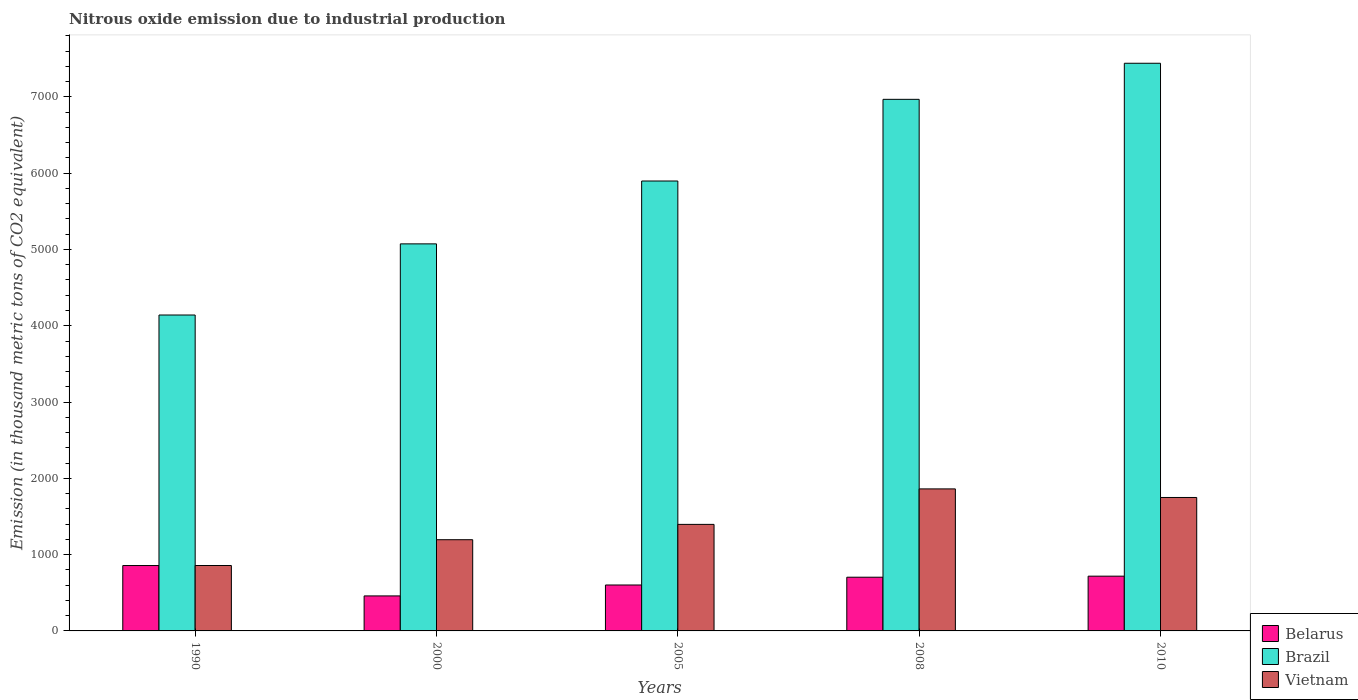How many different coloured bars are there?
Your response must be concise. 3. In how many cases, is the number of bars for a given year not equal to the number of legend labels?
Your answer should be compact. 0. What is the amount of nitrous oxide emitted in Brazil in 2010?
Provide a succinct answer. 7440.7. Across all years, what is the maximum amount of nitrous oxide emitted in Brazil?
Your response must be concise. 7440.7. Across all years, what is the minimum amount of nitrous oxide emitted in Brazil?
Provide a short and direct response. 4140.8. What is the total amount of nitrous oxide emitted in Belarus in the graph?
Provide a succinct answer. 3339.7. What is the difference between the amount of nitrous oxide emitted in Brazil in 2008 and that in 2010?
Keep it short and to the point. -472.8. What is the difference between the amount of nitrous oxide emitted in Brazil in 2005 and the amount of nitrous oxide emitted in Vietnam in 1990?
Provide a short and direct response. 5039.9. What is the average amount of nitrous oxide emitted in Vietnam per year?
Your answer should be compact. 1412.02. In the year 2008, what is the difference between the amount of nitrous oxide emitted in Vietnam and amount of nitrous oxide emitted in Belarus?
Offer a very short reply. 1157.5. What is the ratio of the amount of nitrous oxide emitted in Vietnam in 1990 to that in 2000?
Your response must be concise. 0.72. Is the difference between the amount of nitrous oxide emitted in Vietnam in 2008 and 2010 greater than the difference between the amount of nitrous oxide emitted in Belarus in 2008 and 2010?
Offer a very short reply. Yes. What is the difference between the highest and the second highest amount of nitrous oxide emitted in Vietnam?
Offer a very short reply. 112.5. What is the difference between the highest and the lowest amount of nitrous oxide emitted in Vietnam?
Your answer should be very brief. 1004.2. Is the sum of the amount of nitrous oxide emitted in Belarus in 1990 and 2005 greater than the maximum amount of nitrous oxide emitted in Vietnam across all years?
Your answer should be compact. No. What does the 3rd bar from the left in 2000 represents?
Your answer should be compact. Vietnam. What does the 3rd bar from the right in 2008 represents?
Make the answer very short. Belarus. Are all the bars in the graph horizontal?
Your answer should be very brief. No. What is the difference between two consecutive major ticks on the Y-axis?
Your response must be concise. 1000. Are the values on the major ticks of Y-axis written in scientific E-notation?
Provide a short and direct response. No. Does the graph contain any zero values?
Your response must be concise. No. How many legend labels are there?
Give a very brief answer. 3. How are the legend labels stacked?
Provide a short and direct response. Vertical. What is the title of the graph?
Give a very brief answer. Nitrous oxide emission due to industrial production. What is the label or title of the Y-axis?
Make the answer very short. Emission (in thousand metric tons of CO2 equivalent). What is the Emission (in thousand metric tons of CO2 equivalent) in Belarus in 1990?
Keep it short and to the point. 857. What is the Emission (in thousand metric tons of CO2 equivalent) of Brazil in 1990?
Provide a succinct answer. 4140.8. What is the Emission (in thousand metric tons of CO2 equivalent) of Vietnam in 1990?
Your answer should be very brief. 857.4. What is the Emission (in thousand metric tons of CO2 equivalent) of Belarus in 2000?
Provide a succinct answer. 458.8. What is the Emission (in thousand metric tons of CO2 equivalent) in Brazil in 2000?
Give a very brief answer. 5073.4. What is the Emission (in thousand metric tons of CO2 equivalent) of Vietnam in 2000?
Your answer should be very brief. 1195.6. What is the Emission (in thousand metric tons of CO2 equivalent) in Belarus in 2005?
Provide a short and direct response. 602.1. What is the Emission (in thousand metric tons of CO2 equivalent) of Brazil in 2005?
Your answer should be very brief. 5897.3. What is the Emission (in thousand metric tons of CO2 equivalent) of Vietnam in 2005?
Make the answer very short. 1396.4. What is the Emission (in thousand metric tons of CO2 equivalent) in Belarus in 2008?
Make the answer very short. 704.1. What is the Emission (in thousand metric tons of CO2 equivalent) of Brazil in 2008?
Your response must be concise. 6967.9. What is the Emission (in thousand metric tons of CO2 equivalent) in Vietnam in 2008?
Your answer should be compact. 1861.6. What is the Emission (in thousand metric tons of CO2 equivalent) in Belarus in 2010?
Offer a terse response. 717.7. What is the Emission (in thousand metric tons of CO2 equivalent) of Brazil in 2010?
Make the answer very short. 7440.7. What is the Emission (in thousand metric tons of CO2 equivalent) of Vietnam in 2010?
Ensure brevity in your answer.  1749.1. Across all years, what is the maximum Emission (in thousand metric tons of CO2 equivalent) in Belarus?
Make the answer very short. 857. Across all years, what is the maximum Emission (in thousand metric tons of CO2 equivalent) in Brazil?
Your response must be concise. 7440.7. Across all years, what is the maximum Emission (in thousand metric tons of CO2 equivalent) of Vietnam?
Your answer should be compact. 1861.6. Across all years, what is the minimum Emission (in thousand metric tons of CO2 equivalent) of Belarus?
Your response must be concise. 458.8. Across all years, what is the minimum Emission (in thousand metric tons of CO2 equivalent) in Brazil?
Your answer should be very brief. 4140.8. Across all years, what is the minimum Emission (in thousand metric tons of CO2 equivalent) in Vietnam?
Provide a short and direct response. 857.4. What is the total Emission (in thousand metric tons of CO2 equivalent) of Belarus in the graph?
Your answer should be very brief. 3339.7. What is the total Emission (in thousand metric tons of CO2 equivalent) in Brazil in the graph?
Make the answer very short. 2.95e+04. What is the total Emission (in thousand metric tons of CO2 equivalent) of Vietnam in the graph?
Provide a short and direct response. 7060.1. What is the difference between the Emission (in thousand metric tons of CO2 equivalent) in Belarus in 1990 and that in 2000?
Provide a short and direct response. 398.2. What is the difference between the Emission (in thousand metric tons of CO2 equivalent) of Brazil in 1990 and that in 2000?
Provide a succinct answer. -932.6. What is the difference between the Emission (in thousand metric tons of CO2 equivalent) of Vietnam in 1990 and that in 2000?
Your response must be concise. -338.2. What is the difference between the Emission (in thousand metric tons of CO2 equivalent) in Belarus in 1990 and that in 2005?
Ensure brevity in your answer.  254.9. What is the difference between the Emission (in thousand metric tons of CO2 equivalent) of Brazil in 1990 and that in 2005?
Provide a succinct answer. -1756.5. What is the difference between the Emission (in thousand metric tons of CO2 equivalent) of Vietnam in 1990 and that in 2005?
Keep it short and to the point. -539. What is the difference between the Emission (in thousand metric tons of CO2 equivalent) in Belarus in 1990 and that in 2008?
Keep it short and to the point. 152.9. What is the difference between the Emission (in thousand metric tons of CO2 equivalent) of Brazil in 1990 and that in 2008?
Ensure brevity in your answer.  -2827.1. What is the difference between the Emission (in thousand metric tons of CO2 equivalent) of Vietnam in 1990 and that in 2008?
Keep it short and to the point. -1004.2. What is the difference between the Emission (in thousand metric tons of CO2 equivalent) of Belarus in 1990 and that in 2010?
Your response must be concise. 139.3. What is the difference between the Emission (in thousand metric tons of CO2 equivalent) in Brazil in 1990 and that in 2010?
Your answer should be very brief. -3299.9. What is the difference between the Emission (in thousand metric tons of CO2 equivalent) in Vietnam in 1990 and that in 2010?
Make the answer very short. -891.7. What is the difference between the Emission (in thousand metric tons of CO2 equivalent) of Belarus in 2000 and that in 2005?
Ensure brevity in your answer.  -143.3. What is the difference between the Emission (in thousand metric tons of CO2 equivalent) in Brazil in 2000 and that in 2005?
Keep it short and to the point. -823.9. What is the difference between the Emission (in thousand metric tons of CO2 equivalent) in Vietnam in 2000 and that in 2005?
Give a very brief answer. -200.8. What is the difference between the Emission (in thousand metric tons of CO2 equivalent) of Belarus in 2000 and that in 2008?
Provide a succinct answer. -245.3. What is the difference between the Emission (in thousand metric tons of CO2 equivalent) in Brazil in 2000 and that in 2008?
Offer a terse response. -1894.5. What is the difference between the Emission (in thousand metric tons of CO2 equivalent) of Vietnam in 2000 and that in 2008?
Provide a succinct answer. -666. What is the difference between the Emission (in thousand metric tons of CO2 equivalent) in Belarus in 2000 and that in 2010?
Your response must be concise. -258.9. What is the difference between the Emission (in thousand metric tons of CO2 equivalent) in Brazil in 2000 and that in 2010?
Your response must be concise. -2367.3. What is the difference between the Emission (in thousand metric tons of CO2 equivalent) in Vietnam in 2000 and that in 2010?
Your response must be concise. -553.5. What is the difference between the Emission (in thousand metric tons of CO2 equivalent) of Belarus in 2005 and that in 2008?
Your response must be concise. -102. What is the difference between the Emission (in thousand metric tons of CO2 equivalent) of Brazil in 2005 and that in 2008?
Offer a very short reply. -1070.6. What is the difference between the Emission (in thousand metric tons of CO2 equivalent) of Vietnam in 2005 and that in 2008?
Offer a terse response. -465.2. What is the difference between the Emission (in thousand metric tons of CO2 equivalent) of Belarus in 2005 and that in 2010?
Your response must be concise. -115.6. What is the difference between the Emission (in thousand metric tons of CO2 equivalent) in Brazil in 2005 and that in 2010?
Make the answer very short. -1543.4. What is the difference between the Emission (in thousand metric tons of CO2 equivalent) of Vietnam in 2005 and that in 2010?
Your answer should be very brief. -352.7. What is the difference between the Emission (in thousand metric tons of CO2 equivalent) of Belarus in 2008 and that in 2010?
Your response must be concise. -13.6. What is the difference between the Emission (in thousand metric tons of CO2 equivalent) in Brazil in 2008 and that in 2010?
Give a very brief answer. -472.8. What is the difference between the Emission (in thousand metric tons of CO2 equivalent) of Vietnam in 2008 and that in 2010?
Provide a short and direct response. 112.5. What is the difference between the Emission (in thousand metric tons of CO2 equivalent) of Belarus in 1990 and the Emission (in thousand metric tons of CO2 equivalent) of Brazil in 2000?
Provide a succinct answer. -4216.4. What is the difference between the Emission (in thousand metric tons of CO2 equivalent) of Belarus in 1990 and the Emission (in thousand metric tons of CO2 equivalent) of Vietnam in 2000?
Provide a short and direct response. -338.6. What is the difference between the Emission (in thousand metric tons of CO2 equivalent) in Brazil in 1990 and the Emission (in thousand metric tons of CO2 equivalent) in Vietnam in 2000?
Offer a terse response. 2945.2. What is the difference between the Emission (in thousand metric tons of CO2 equivalent) in Belarus in 1990 and the Emission (in thousand metric tons of CO2 equivalent) in Brazil in 2005?
Give a very brief answer. -5040.3. What is the difference between the Emission (in thousand metric tons of CO2 equivalent) in Belarus in 1990 and the Emission (in thousand metric tons of CO2 equivalent) in Vietnam in 2005?
Offer a terse response. -539.4. What is the difference between the Emission (in thousand metric tons of CO2 equivalent) in Brazil in 1990 and the Emission (in thousand metric tons of CO2 equivalent) in Vietnam in 2005?
Provide a short and direct response. 2744.4. What is the difference between the Emission (in thousand metric tons of CO2 equivalent) in Belarus in 1990 and the Emission (in thousand metric tons of CO2 equivalent) in Brazil in 2008?
Make the answer very short. -6110.9. What is the difference between the Emission (in thousand metric tons of CO2 equivalent) in Belarus in 1990 and the Emission (in thousand metric tons of CO2 equivalent) in Vietnam in 2008?
Keep it short and to the point. -1004.6. What is the difference between the Emission (in thousand metric tons of CO2 equivalent) of Brazil in 1990 and the Emission (in thousand metric tons of CO2 equivalent) of Vietnam in 2008?
Keep it short and to the point. 2279.2. What is the difference between the Emission (in thousand metric tons of CO2 equivalent) of Belarus in 1990 and the Emission (in thousand metric tons of CO2 equivalent) of Brazil in 2010?
Make the answer very short. -6583.7. What is the difference between the Emission (in thousand metric tons of CO2 equivalent) of Belarus in 1990 and the Emission (in thousand metric tons of CO2 equivalent) of Vietnam in 2010?
Make the answer very short. -892.1. What is the difference between the Emission (in thousand metric tons of CO2 equivalent) of Brazil in 1990 and the Emission (in thousand metric tons of CO2 equivalent) of Vietnam in 2010?
Make the answer very short. 2391.7. What is the difference between the Emission (in thousand metric tons of CO2 equivalent) in Belarus in 2000 and the Emission (in thousand metric tons of CO2 equivalent) in Brazil in 2005?
Your answer should be compact. -5438.5. What is the difference between the Emission (in thousand metric tons of CO2 equivalent) of Belarus in 2000 and the Emission (in thousand metric tons of CO2 equivalent) of Vietnam in 2005?
Your response must be concise. -937.6. What is the difference between the Emission (in thousand metric tons of CO2 equivalent) in Brazil in 2000 and the Emission (in thousand metric tons of CO2 equivalent) in Vietnam in 2005?
Your response must be concise. 3677. What is the difference between the Emission (in thousand metric tons of CO2 equivalent) of Belarus in 2000 and the Emission (in thousand metric tons of CO2 equivalent) of Brazil in 2008?
Offer a very short reply. -6509.1. What is the difference between the Emission (in thousand metric tons of CO2 equivalent) of Belarus in 2000 and the Emission (in thousand metric tons of CO2 equivalent) of Vietnam in 2008?
Your answer should be compact. -1402.8. What is the difference between the Emission (in thousand metric tons of CO2 equivalent) in Brazil in 2000 and the Emission (in thousand metric tons of CO2 equivalent) in Vietnam in 2008?
Offer a very short reply. 3211.8. What is the difference between the Emission (in thousand metric tons of CO2 equivalent) in Belarus in 2000 and the Emission (in thousand metric tons of CO2 equivalent) in Brazil in 2010?
Your response must be concise. -6981.9. What is the difference between the Emission (in thousand metric tons of CO2 equivalent) in Belarus in 2000 and the Emission (in thousand metric tons of CO2 equivalent) in Vietnam in 2010?
Keep it short and to the point. -1290.3. What is the difference between the Emission (in thousand metric tons of CO2 equivalent) in Brazil in 2000 and the Emission (in thousand metric tons of CO2 equivalent) in Vietnam in 2010?
Keep it short and to the point. 3324.3. What is the difference between the Emission (in thousand metric tons of CO2 equivalent) in Belarus in 2005 and the Emission (in thousand metric tons of CO2 equivalent) in Brazil in 2008?
Your answer should be compact. -6365.8. What is the difference between the Emission (in thousand metric tons of CO2 equivalent) in Belarus in 2005 and the Emission (in thousand metric tons of CO2 equivalent) in Vietnam in 2008?
Provide a short and direct response. -1259.5. What is the difference between the Emission (in thousand metric tons of CO2 equivalent) of Brazil in 2005 and the Emission (in thousand metric tons of CO2 equivalent) of Vietnam in 2008?
Offer a very short reply. 4035.7. What is the difference between the Emission (in thousand metric tons of CO2 equivalent) in Belarus in 2005 and the Emission (in thousand metric tons of CO2 equivalent) in Brazil in 2010?
Your answer should be compact. -6838.6. What is the difference between the Emission (in thousand metric tons of CO2 equivalent) in Belarus in 2005 and the Emission (in thousand metric tons of CO2 equivalent) in Vietnam in 2010?
Your answer should be compact. -1147. What is the difference between the Emission (in thousand metric tons of CO2 equivalent) in Brazil in 2005 and the Emission (in thousand metric tons of CO2 equivalent) in Vietnam in 2010?
Keep it short and to the point. 4148.2. What is the difference between the Emission (in thousand metric tons of CO2 equivalent) in Belarus in 2008 and the Emission (in thousand metric tons of CO2 equivalent) in Brazil in 2010?
Keep it short and to the point. -6736.6. What is the difference between the Emission (in thousand metric tons of CO2 equivalent) of Belarus in 2008 and the Emission (in thousand metric tons of CO2 equivalent) of Vietnam in 2010?
Offer a very short reply. -1045. What is the difference between the Emission (in thousand metric tons of CO2 equivalent) of Brazil in 2008 and the Emission (in thousand metric tons of CO2 equivalent) of Vietnam in 2010?
Offer a terse response. 5218.8. What is the average Emission (in thousand metric tons of CO2 equivalent) of Belarus per year?
Your answer should be compact. 667.94. What is the average Emission (in thousand metric tons of CO2 equivalent) of Brazil per year?
Your answer should be compact. 5904.02. What is the average Emission (in thousand metric tons of CO2 equivalent) in Vietnam per year?
Keep it short and to the point. 1412.02. In the year 1990, what is the difference between the Emission (in thousand metric tons of CO2 equivalent) in Belarus and Emission (in thousand metric tons of CO2 equivalent) in Brazil?
Keep it short and to the point. -3283.8. In the year 1990, what is the difference between the Emission (in thousand metric tons of CO2 equivalent) of Belarus and Emission (in thousand metric tons of CO2 equivalent) of Vietnam?
Your response must be concise. -0.4. In the year 1990, what is the difference between the Emission (in thousand metric tons of CO2 equivalent) in Brazil and Emission (in thousand metric tons of CO2 equivalent) in Vietnam?
Offer a very short reply. 3283.4. In the year 2000, what is the difference between the Emission (in thousand metric tons of CO2 equivalent) of Belarus and Emission (in thousand metric tons of CO2 equivalent) of Brazil?
Provide a short and direct response. -4614.6. In the year 2000, what is the difference between the Emission (in thousand metric tons of CO2 equivalent) in Belarus and Emission (in thousand metric tons of CO2 equivalent) in Vietnam?
Make the answer very short. -736.8. In the year 2000, what is the difference between the Emission (in thousand metric tons of CO2 equivalent) of Brazil and Emission (in thousand metric tons of CO2 equivalent) of Vietnam?
Offer a terse response. 3877.8. In the year 2005, what is the difference between the Emission (in thousand metric tons of CO2 equivalent) of Belarus and Emission (in thousand metric tons of CO2 equivalent) of Brazil?
Offer a terse response. -5295.2. In the year 2005, what is the difference between the Emission (in thousand metric tons of CO2 equivalent) in Belarus and Emission (in thousand metric tons of CO2 equivalent) in Vietnam?
Your response must be concise. -794.3. In the year 2005, what is the difference between the Emission (in thousand metric tons of CO2 equivalent) of Brazil and Emission (in thousand metric tons of CO2 equivalent) of Vietnam?
Your answer should be very brief. 4500.9. In the year 2008, what is the difference between the Emission (in thousand metric tons of CO2 equivalent) in Belarus and Emission (in thousand metric tons of CO2 equivalent) in Brazil?
Provide a short and direct response. -6263.8. In the year 2008, what is the difference between the Emission (in thousand metric tons of CO2 equivalent) of Belarus and Emission (in thousand metric tons of CO2 equivalent) of Vietnam?
Your answer should be compact. -1157.5. In the year 2008, what is the difference between the Emission (in thousand metric tons of CO2 equivalent) of Brazil and Emission (in thousand metric tons of CO2 equivalent) of Vietnam?
Your response must be concise. 5106.3. In the year 2010, what is the difference between the Emission (in thousand metric tons of CO2 equivalent) in Belarus and Emission (in thousand metric tons of CO2 equivalent) in Brazil?
Make the answer very short. -6723. In the year 2010, what is the difference between the Emission (in thousand metric tons of CO2 equivalent) of Belarus and Emission (in thousand metric tons of CO2 equivalent) of Vietnam?
Ensure brevity in your answer.  -1031.4. In the year 2010, what is the difference between the Emission (in thousand metric tons of CO2 equivalent) in Brazil and Emission (in thousand metric tons of CO2 equivalent) in Vietnam?
Give a very brief answer. 5691.6. What is the ratio of the Emission (in thousand metric tons of CO2 equivalent) in Belarus in 1990 to that in 2000?
Offer a very short reply. 1.87. What is the ratio of the Emission (in thousand metric tons of CO2 equivalent) of Brazil in 1990 to that in 2000?
Ensure brevity in your answer.  0.82. What is the ratio of the Emission (in thousand metric tons of CO2 equivalent) in Vietnam in 1990 to that in 2000?
Your answer should be very brief. 0.72. What is the ratio of the Emission (in thousand metric tons of CO2 equivalent) of Belarus in 1990 to that in 2005?
Make the answer very short. 1.42. What is the ratio of the Emission (in thousand metric tons of CO2 equivalent) of Brazil in 1990 to that in 2005?
Your answer should be very brief. 0.7. What is the ratio of the Emission (in thousand metric tons of CO2 equivalent) of Vietnam in 1990 to that in 2005?
Provide a short and direct response. 0.61. What is the ratio of the Emission (in thousand metric tons of CO2 equivalent) of Belarus in 1990 to that in 2008?
Keep it short and to the point. 1.22. What is the ratio of the Emission (in thousand metric tons of CO2 equivalent) of Brazil in 1990 to that in 2008?
Keep it short and to the point. 0.59. What is the ratio of the Emission (in thousand metric tons of CO2 equivalent) in Vietnam in 1990 to that in 2008?
Provide a short and direct response. 0.46. What is the ratio of the Emission (in thousand metric tons of CO2 equivalent) in Belarus in 1990 to that in 2010?
Offer a terse response. 1.19. What is the ratio of the Emission (in thousand metric tons of CO2 equivalent) of Brazil in 1990 to that in 2010?
Offer a terse response. 0.56. What is the ratio of the Emission (in thousand metric tons of CO2 equivalent) of Vietnam in 1990 to that in 2010?
Provide a short and direct response. 0.49. What is the ratio of the Emission (in thousand metric tons of CO2 equivalent) of Belarus in 2000 to that in 2005?
Give a very brief answer. 0.76. What is the ratio of the Emission (in thousand metric tons of CO2 equivalent) of Brazil in 2000 to that in 2005?
Your answer should be compact. 0.86. What is the ratio of the Emission (in thousand metric tons of CO2 equivalent) in Vietnam in 2000 to that in 2005?
Keep it short and to the point. 0.86. What is the ratio of the Emission (in thousand metric tons of CO2 equivalent) of Belarus in 2000 to that in 2008?
Your answer should be compact. 0.65. What is the ratio of the Emission (in thousand metric tons of CO2 equivalent) in Brazil in 2000 to that in 2008?
Ensure brevity in your answer.  0.73. What is the ratio of the Emission (in thousand metric tons of CO2 equivalent) in Vietnam in 2000 to that in 2008?
Keep it short and to the point. 0.64. What is the ratio of the Emission (in thousand metric tons of CO2 equivalent) of Belarus in 2000 to that in 2010?
Offer a terse response. 0.64. What is the ratio of the Emission (in thousand metric tons of CO2 equivalent) in Brazil in 2000 to that in 2010?
Keep it short and to the point. 0.68. What is the ratio of the Emission (in thousand metric tons of CO2 equivalent) of Vietnam in 2000 to that in 2010?
Provide a succinct answer. 0.68. What is the ratio of the Emission (in thousand metric tons of CO2 equivalent) of Belarus in 2005 to that in 2008?
Make the answer very short. 0.86. What is the ratio of the Emission (in thousand metric tons of CO2 equivalent) in Brazil in 2005 to that in 2008?
Provide a succinct answer. 0.85. What is the ratio of the Emission (in thousand metric tons of CO2 equivalent) in Vietnam in 2005 to that in 2008?
Make the answer very short. 0.75. What is the ratio of the Emission (in thousand metric tons of CO2 equivalent) of Belarus in 2005 to that in 2010?
Your answer should be very brief. 0.84. What is the ratio of the Emission (in thousand metric tons of CO2 equivalent) of Brazil in 2005 to that in 2010?
Provide a short and direct response. 0.79. What is the ratio of the Emission (in thousand metric tons of CO2 equivalent) in Vietnam in 2005 to that in 2010?
Give a very brief answer. 0.8. What is the ratio of the Emission (in thousand metric tons of CO2 equivalent) of Belarus in 2008 to that in 2010?
Provide a short and direct response. 0.98. What is the ratio of the Emission (in thousand metric tons of CO2 equivalent) of Brazil in 2008 to that in 2010?
Your response must be concise. 0.94. What is the ratio of the Emission (in thousand metric tons of CO2 equivalent) in Vietnam in 2008 to that in 2010?
Your answer should be compact. 1.06. What is the difference between the highest and the second highest Emission (in thousand metric tons of CO2 equivalent) of Belarus?
Give a very brief answer. 139.3. What is the difference between the highest and the second highest Emission (in thousand metric tons of CO2 equivalent) in Brazil?
Keep it short and to the point. 472.8. What is the difference between the highest and the second highest Emission (in thousand metric tons of CO2 equivalent) of Vietnam?
Ensure brevity in your answer.  112.5. What is the difference between the highest and the lowest Emission (in thousand metric tons of CO2 equivalent) of Belarus?
Give a very brief answer. 398.2. What is the difference between the highest and the lowest Emission (in thousand metric tons of CO2 equivalent) of Brazil?
Keep it short and to the point. 3299.9. What is the difference between the highest and the lowest Emission (in thousand metric tons of CO2 equivalent) in Vietnam?
Give a very brief answer. 1004.2. 